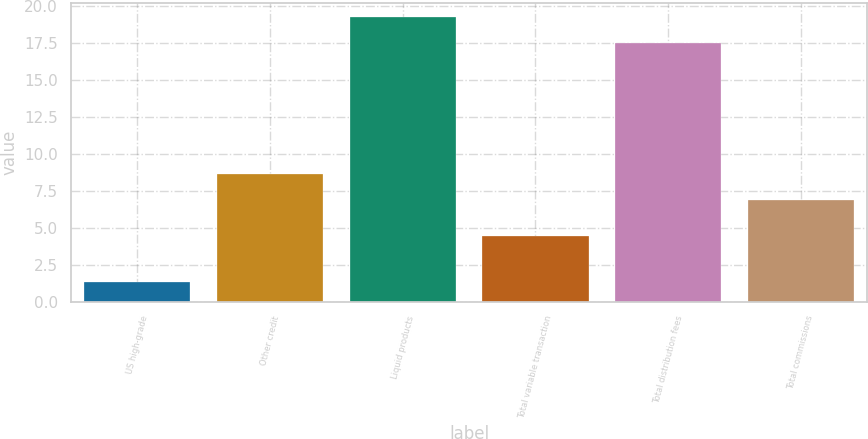<chart> <loc_0><loc_0><loc_500><loc_500><bar_chart><fcel>US high-grade<fcel>Other credit<fcel>Liquid products<fcel>Total variable transaction<fcel>Total distribution fees<fcel>Total commissions<nl><fcel>1.3<fcel>8.62<fcel>19.22<fcel>4.4<fcel>17.5<fcel>6.9<nl></chart> 